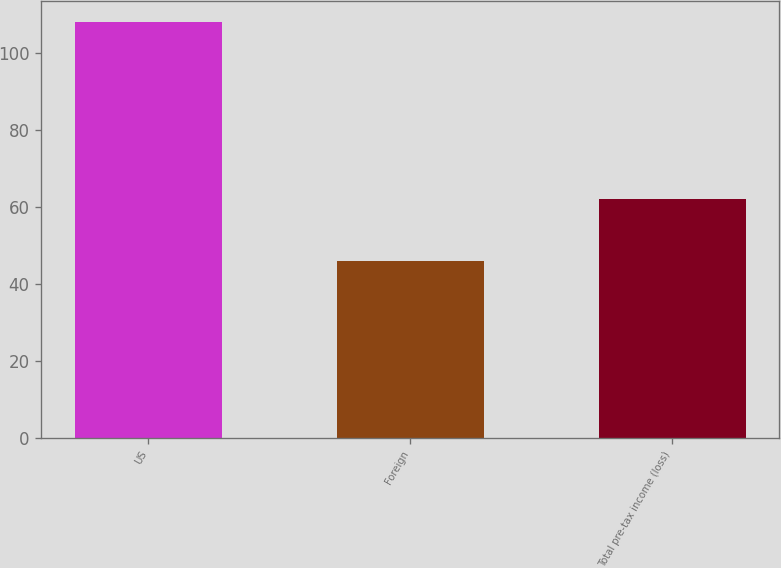<chart> <loc_0><loc_0><loc_500><loc_500><bar_chart><fcel>US<fcel>Foreign<fcel>Total pre-tax income (loss)<nl><fcel>108<fcel>46<fcel>62<nl></chart> 